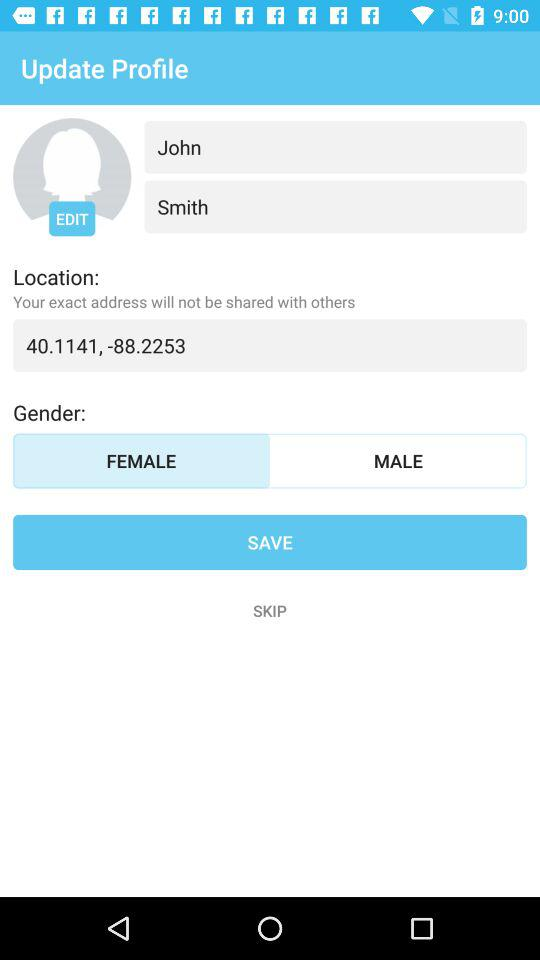What is the location given on the screen? The given location is 40.1141, -88.2253. 